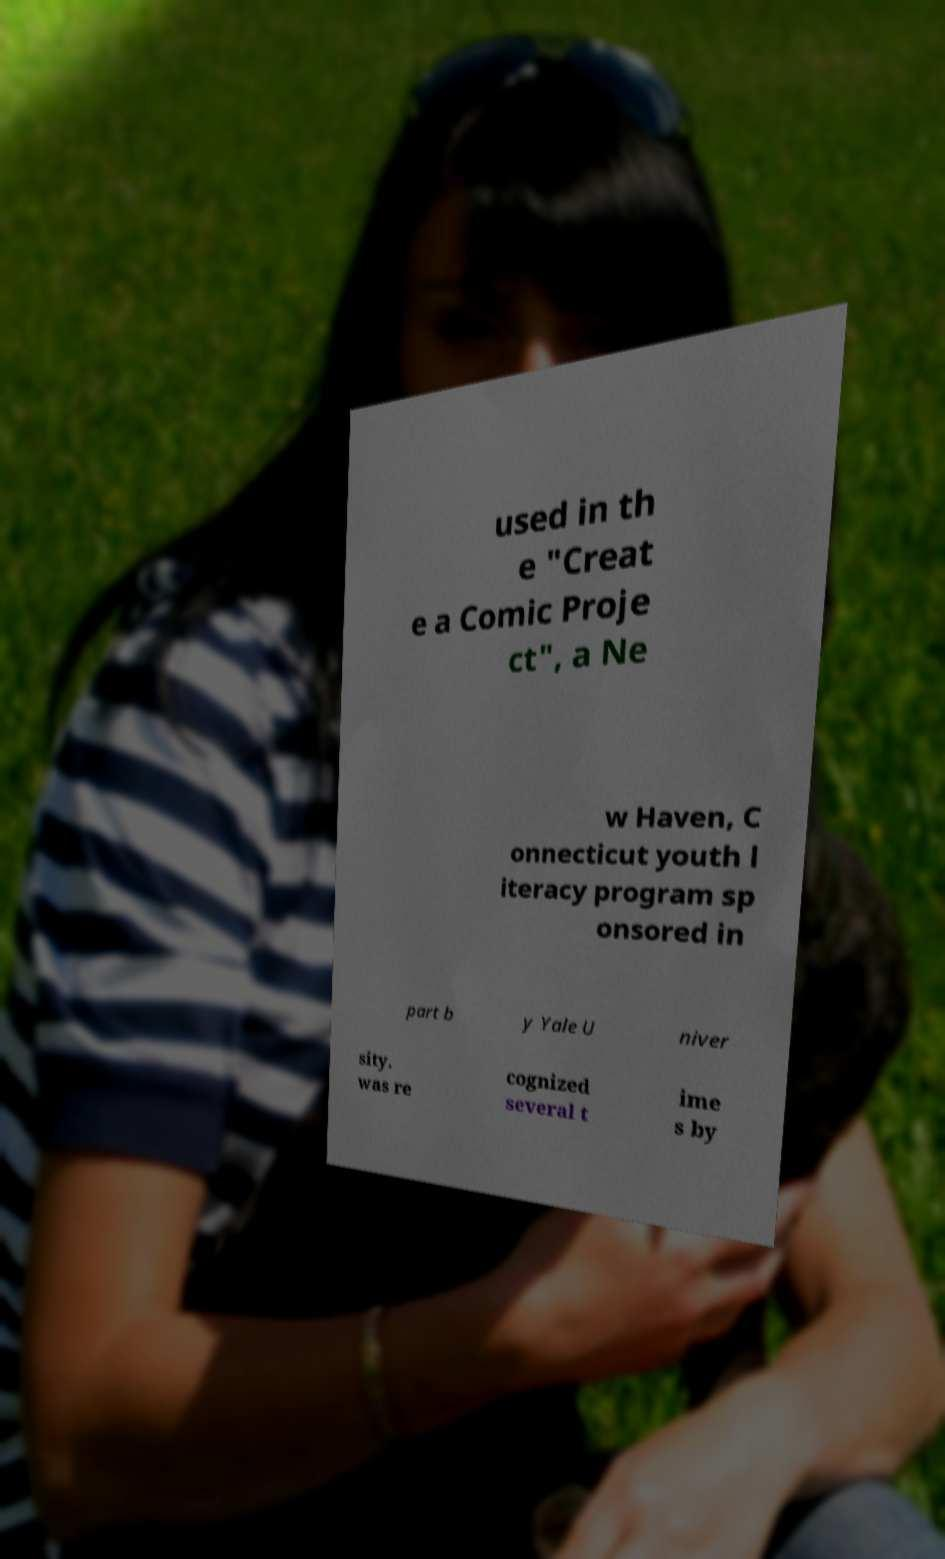What messages or text are displayed in this image? I need them in a readable, typed format. used in th e "Creat e a Comic Proje ct", a Ne w Haven, C onnecticut youth l iteracy program sp onsored in part b y Yale U niver sity. was re cognized several t ime s by 